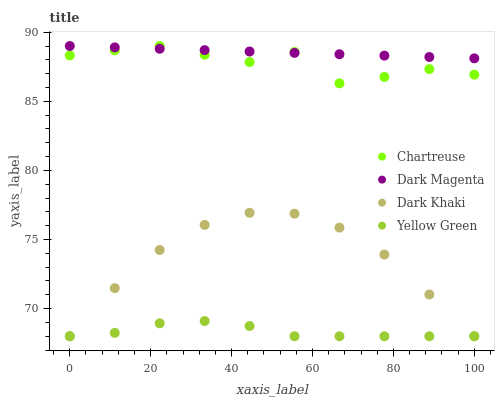Does Yellow Green have the minimum area under the curve?
Answer yes or no. Yes. Does Dark Magenta have the maximum area under the curve?
Answer yes or no. Yes. Does Chartreuse have the minimum area under the curve?
Answer yes or no. No. Does Chartreuse have the maximum area under the curve?
Answer yes or no. No. Is Dark Magenta the smoothest?
Answer yes or no. Yes. Is Chartreuse the roughest?
Answer yes or no. Yes. Is Chartreuse the smoothest?
Answer yes or no. No. Is Dark Magenta the roughest?
Answer yes or no. No. Does Dark Khaki have the lowest value?
Answer yes or no. Yes. Does Chartreuse have the lowest value?
Answer yes or no. No. Does Dark Magenta have the highest value?
Answer yes or no. Yes. Does Yellow Green have the highest value?
Answer yes or no. No. Is Dark Khaki less than Dark Magenta?
Answer yes or no. Yes. Is Chartreuse greater than Yellow Green?
Answer yes or no. Yes. Does Chartreuse intersect Dark Magenta?
Answer yes or no. Yes. Is Chartreuse less than Dark Magenta?
Answer yes or no. No. Is Chartreuse greater than Dark Magenta?
Answer yes or no. No. Does Dark Khaki intersect Dark Magenta?
Answer yes or no. No. 